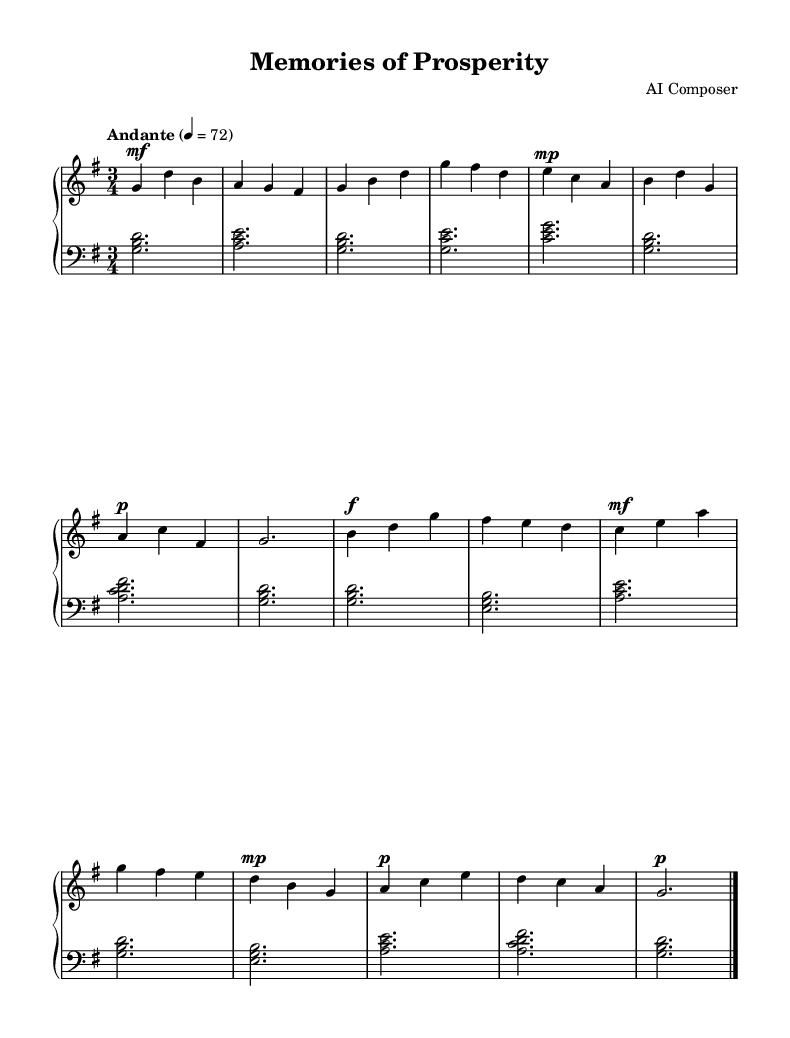What is the key signature of this music? The key signature is G major, which has one sharp (F#). This can be identified by looking at the key signature at the beginning of the staff.
Answer: G major What is the time signature of this music? The time signature is 3/4, which is indicated at the beginning of the sheet music. This means there are three beats in each measure.
Answer: 3/4 What is the tempo marking for this piece? The tempo marking is "Andante," which suggests a moderate pace. This is noted right above the staff in the tempo indication section.
Answer: Andante What is the dynamic marking of the first measure? The dynamic marking of the first measure is "mf," which stands for mezzo-forte, meaning moderately loud. It can be seen directly under the first note in the upper staff.
Answer: mf Which measure features a key change? There is no key change in the piece as it remains in G major throughout. By analyzing the note patterns, they consistently align with the G major scale.
Answer: None What is the primary musical theme of this piece? The primary musical theme is nostalgic, reflecting a sense of pre-conflict prosperity. This can be inferred from the melody's lyrical quality and the overall mood conveyed through the note choices and dynamics.
Answer: Nostalgic How does the bass clef support the melody? The bass clef provides harmonic support by outlining chords that complement the melody in the treble clef. Observing the bass notes, they form the roots of the chords that enhance the emotional weight of the melody.
Answer: Harmonic support 